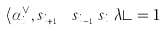Convert formula to latex. <formula><loc_0><loc_0><loc_500><loc_500>\langle \alpha _ { i _ { k } } ^ { \vee } , s _ { i _ { k + 1 } } \cdots s _ { i _ { \ell - 1 } } s _ { i _ { \ell } } \lambda \rangle = 1</formula> 